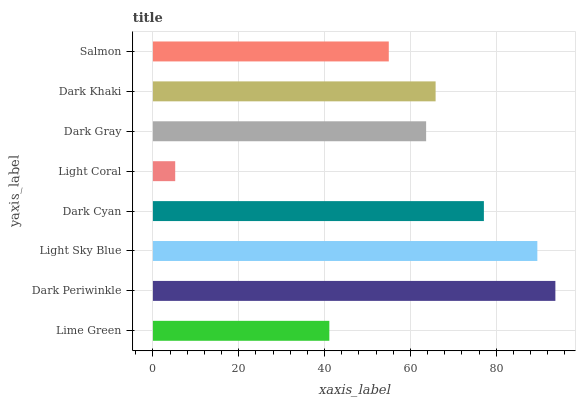Is Light Coral the minimum?
Answer yes or no. Yes. Is Dark Periwinkle the maximum?
Answer yes or no. Yes. Is Light Sky Blue the minimum?
Answer yes or no. No. Is Light Sky Blue the maximum?
Answer yes or no. No. Is Dark Periwinkle greater than Light Sky Blue?
Answer yes or no. Yes. Is Light Sky Blue less than Dark Periwinkle?
Answer yes or no. Yes. Is Light Sky Blue greater than Dark Periwinkle?
Answer yes or no. No. Is Dark Periwinkle less than Light Sky Blue?
Answer yes or no. No. Is Dark Khaki the high median?
Answer yes or no. Yes. Is Dark Gray the low median?
Answer yes or no. Yes. Is Light Sky Blue the high median?
Answer yes or no. No. Is Lime Green the low median?
Answer yes or no. No. 